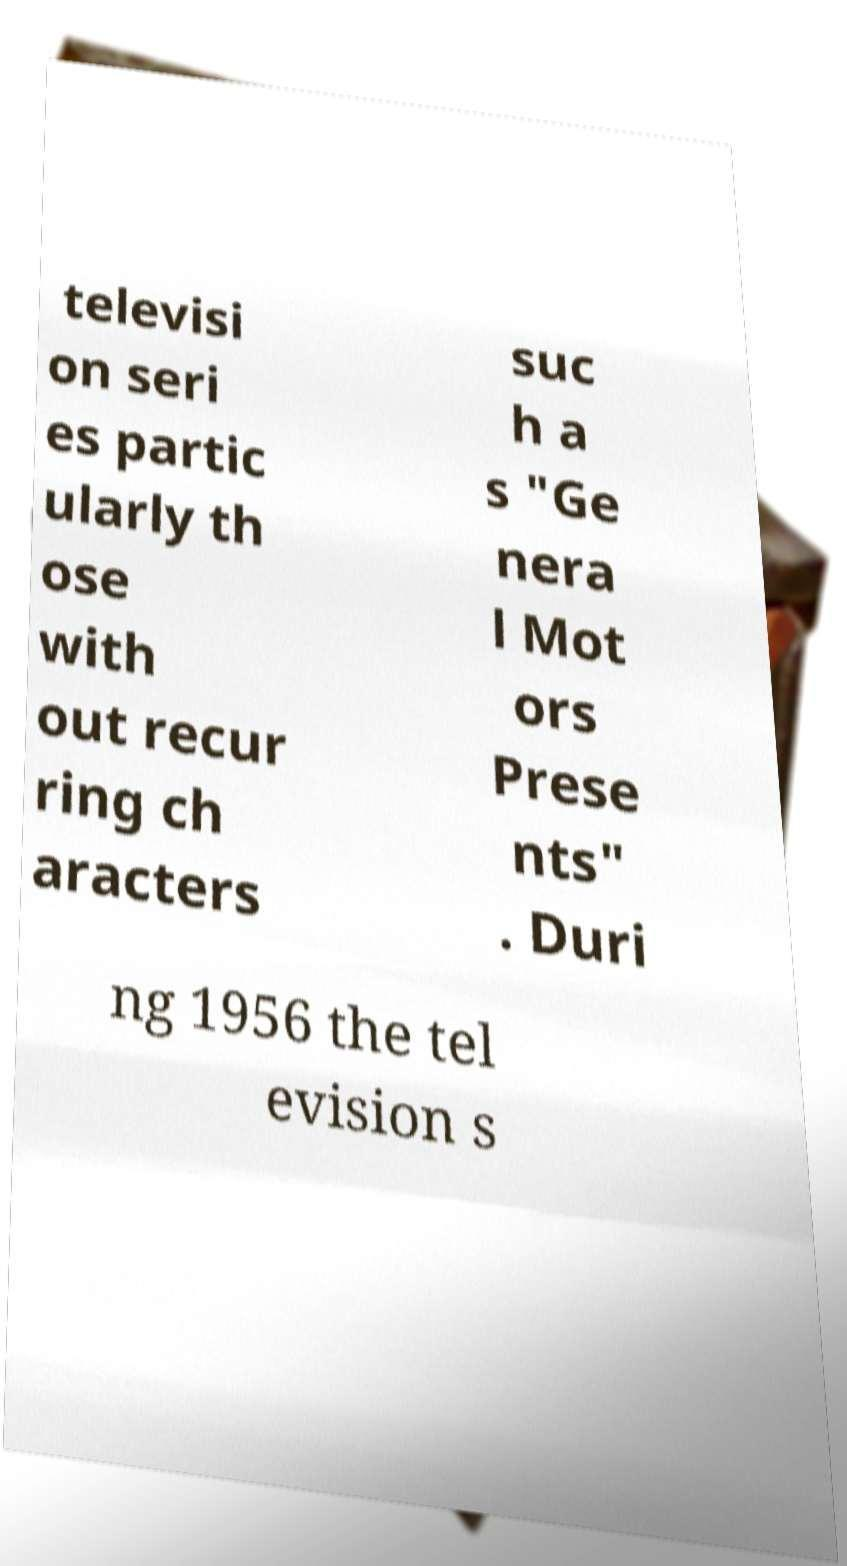Please identify and transcribe the text found in this image. televisi on seri es partic ularly th ose with out recur ring ch aracters suc h a s "Ge nera l Mot ors Prese nts" . Duri ng 1956 the tel evision s 